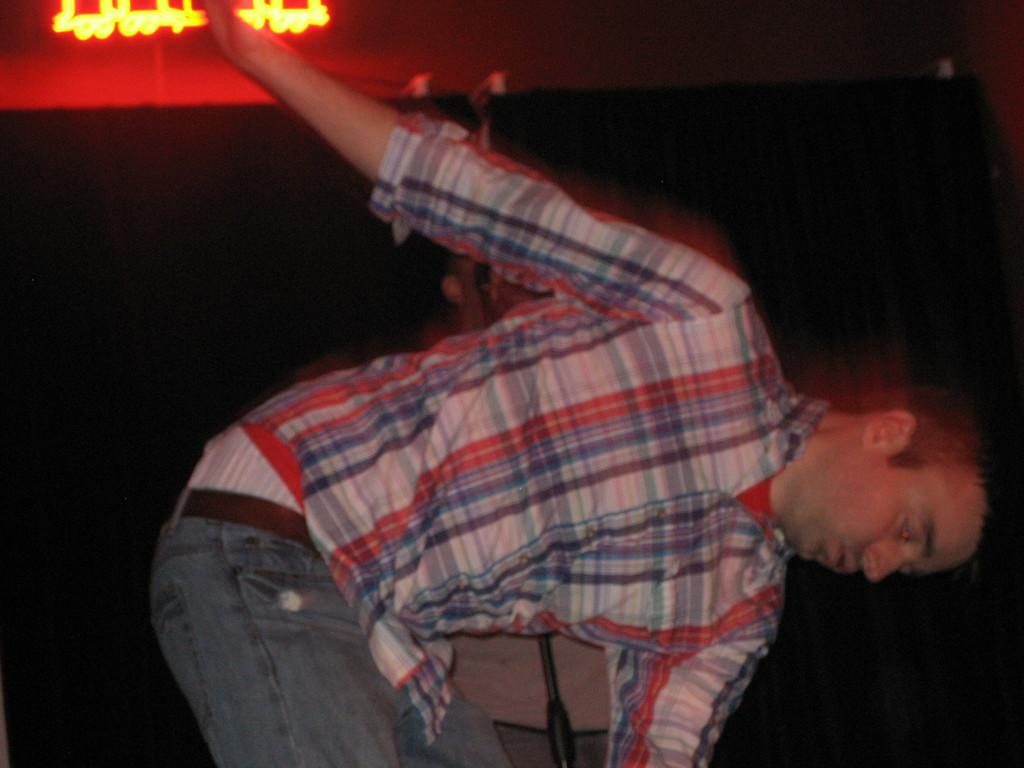Who is present in the image? There is a man in the image. What can be seen at the left top of the image? There is a light at the left top of the image. Can you describe the background of the image? The background of the image is blurry. What type of corn is being used in the war depicted in the image? There is no war or corn present in the image; it features a man and a light in a blurry background. 